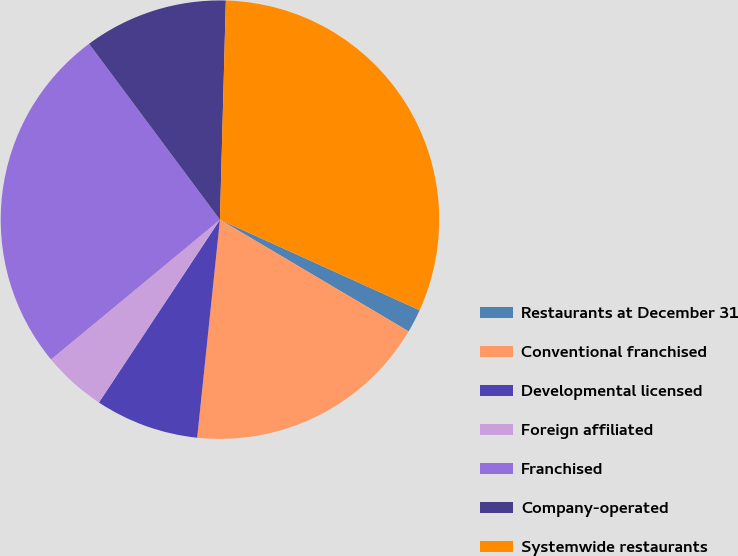Convert chart. <chart><loc_0><loc_0><loc_500><loc_500><pie_chart><fcel>Restaurants at December 31<fcel>Conventional franchised<fcel>Developmental licensed<fcel>Foreign affiliated<fcel>Franchised<fcel>Company-operated<fcel>Systemwide restaurants<nl><fcel>1.73%<fcel>18.15%<fcel>7.65%<fcel>4.69%<fcel>25.82%<fcel>10.61%<fcel>31.35%<nl></chart> 